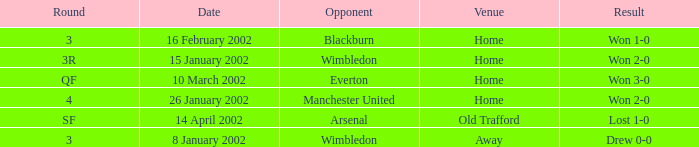What is the Round with a Opponent with blackburn? 3.0. Could you parse the entire table? {'header': ['Round', 'Date', 'Opponent', 'Venue', 'Result'], 'rows': [['3', '16 February 2002', 'Blackburn', 'Home', 'Won 1-0'], ['3R', '15 January 2002', 'Wimbledon', 'Home', 'Won 2-0'], ['QF', '10 March 2002', 'Everton', 'Home', 'Won 3-0'], ['4', '26 January 2002', 'Manchester United', 'Home', 'Won 2-0'], ['SF', '14 April 2002', 'Arsenal', 'Old Trafford', 'Lost 1-0'], ['3', '8 January 2002', 'Wimbledon', 'Away', 'Drew 0-0']]} 